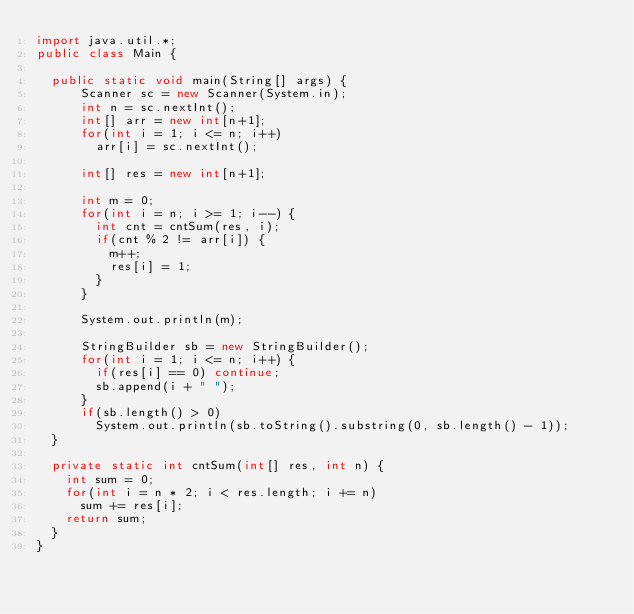Convert code to text. <code><loc_0><loc_0><loc_500><loc_500><_Java_>import java.util.*;
public class Main {

  public static void main(String[] args) { 
      Scanner sc = new Scanner(System.in);
      int n = sc.nextInt();
      int[] arr = new int[n+1];
      for(int i = 1; i <= n; i++)
        arr[i] = sc.nextInt();

      int[] res = new int[n+1];

      int m = 0;
      for(int i = n; i >= 1; i--) {
        int cnt = cntSum(res, i);
        if(cnt % 2 != arr[i]) {
          m++;
          res[i] = 1;
        }
      }
      
      System.out.println(m);
      
      StringBuilder sb = new StringBuilder();
      for(int i = 1; i <= n; i++) {
        if(res[i] == 0) continue;
        sb.append(i + " ");
      }
      if(sb.length() > 0)
        System.out.println(sb.toString().substring(0, sb.length() - 1));
  }

  private static int cntSum(int[] res, int n) {
    int sum = 0;
    for(int i = n * 2; i < res.length; i += n)
      sum += res[i];
    return sum;
  }
}</code> 